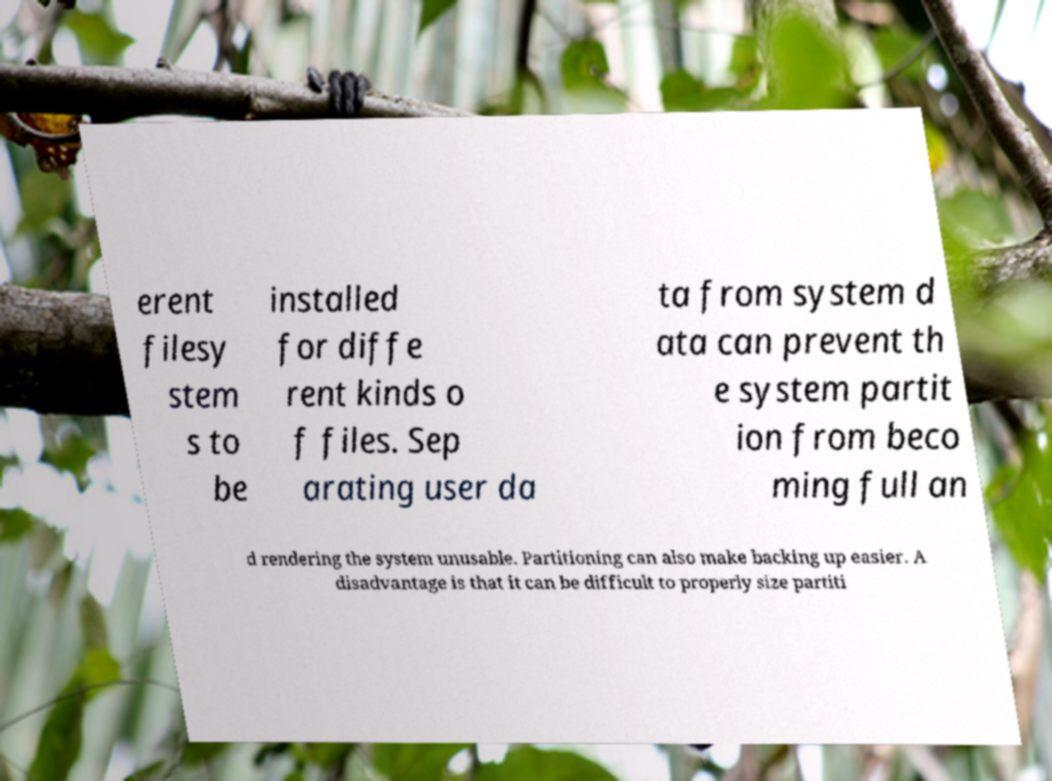What messages or text are displayed in this image? I need them in a readable, typed format. erent filesy stem s to be installed for diffe rent kinds o f files. Sep arating user da ta from system d ata can prevent th e system partit ion from beco ming full an d rendering the system unusable. Partitioning can also make backing up easier. A disadvantage is that it can be difficult to properly size partiti 